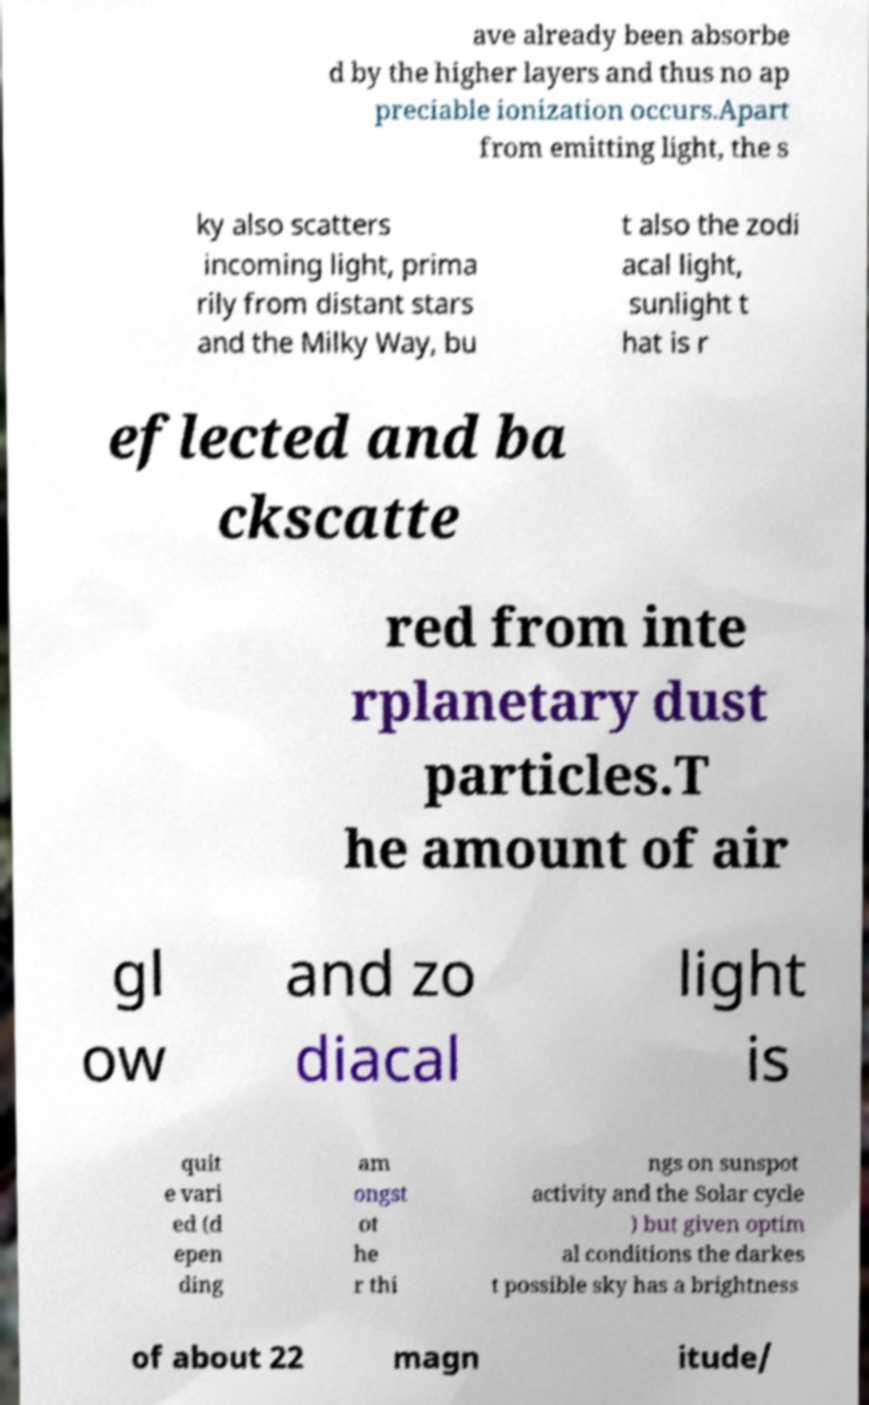Please read and relay the text visible in this image. What does it say? ave already been absorbe d by the higher layers and thus no ap preciable ionization occurs.Apart from emitting light, the s ky also scatters incoming light, prima rily from distant stars and the Milky Way, bu t also the zodi acal light, sunlight t hat is r eflected and ba ckscatte red from inte rplanetary dust particles.T he amount of air gl ow and zo diacal light is quit e vari ed (d epen ding am ongst ot he r thi ngs on sunspot activity and the Solar cycle ) but given optim al conditions the darkes t possible sky has a brightness of about 22 magn itude/ 